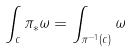Convert formula to latex. <formula><loc_0><loc_0><loc_500><loc_500>\int _ { c } \pi _ { * } \omega = \int _ { \pi ^ { - 1 } ( c ) } \omega</formula> 